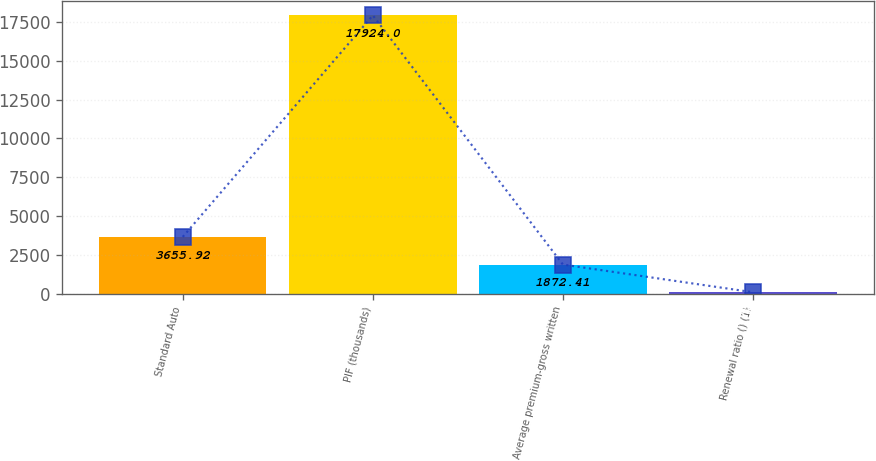<chart> <loc_0><loc_0><loc_500><loc_500><bar_chart><fcel>Standard Auto<fcel>PIF (thousands)<fcel>Average premium-gross written<fcel>Renewal ratio () (1)<nl><fcel>3655.92<fcel>17924<fcel>1872.41<fcel>88.9<nl></chart> 